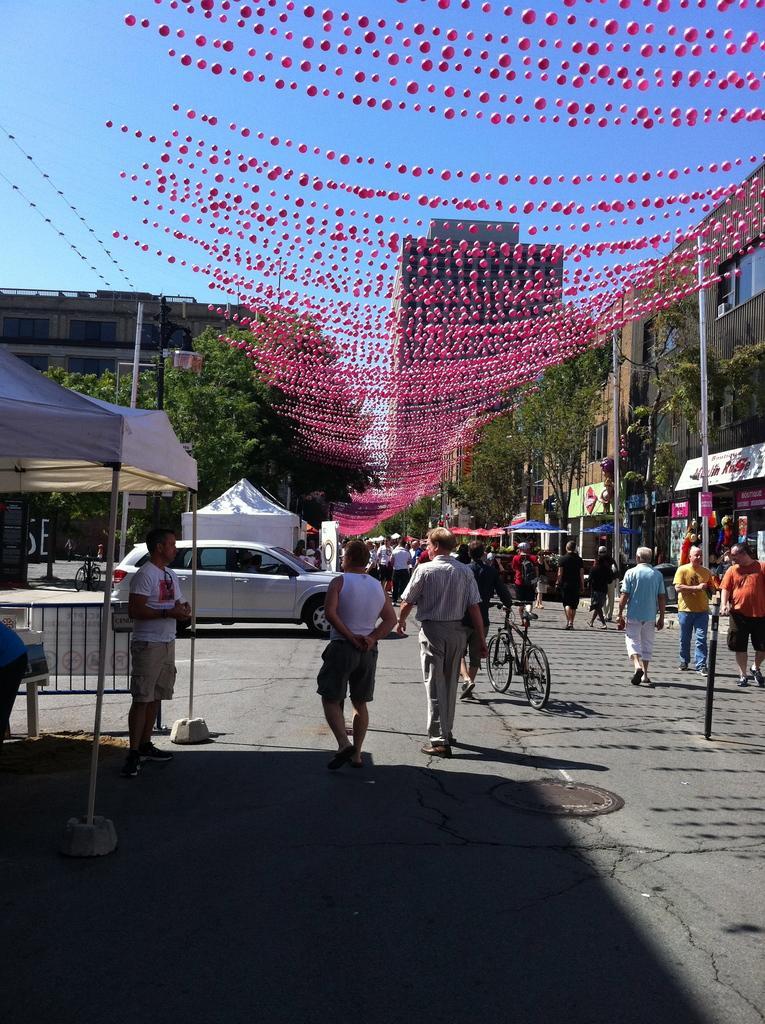Could you give a brief overview of what you see in this image? This is an outside view. Here I can see many people are walking on the road and there are few vehicles. On both sides of the road there are many poles. On the left side there are two tents. In the background there are many trees and buildings. At the top there is some decoration. At the top of the image I can see the sky in blue color. 